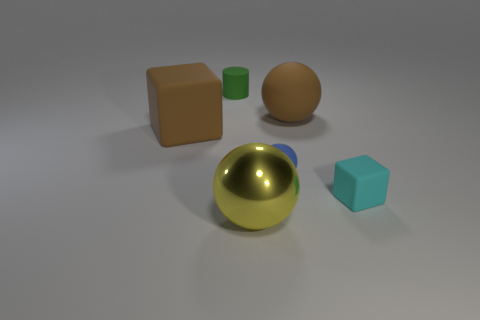Subtract all large yellow metallic spheres. How many spheres are left? 2 Add 2 tiny rubber balls. How many objects exist? 8 Subtract all brown balls. How many balls are left? 2 Subtract all blocks. How many objects are left? 4 Subtract 1 blocks. How many blocks are left? 1 Add 2 big brown metal spheres. How many big brown metal spheres exist? 2 Subtract 0 purple cylinders. How many objects are left? 6 Subtract all gray cubes. Subtract all red spheres. How many cubes are left? 2 Subtract all tiny purple matte cubes. Subtract all tiny green things. How many objects are left? 5 Add 5 tiny blue matte things. How many tiny blue matte things are left? 6 